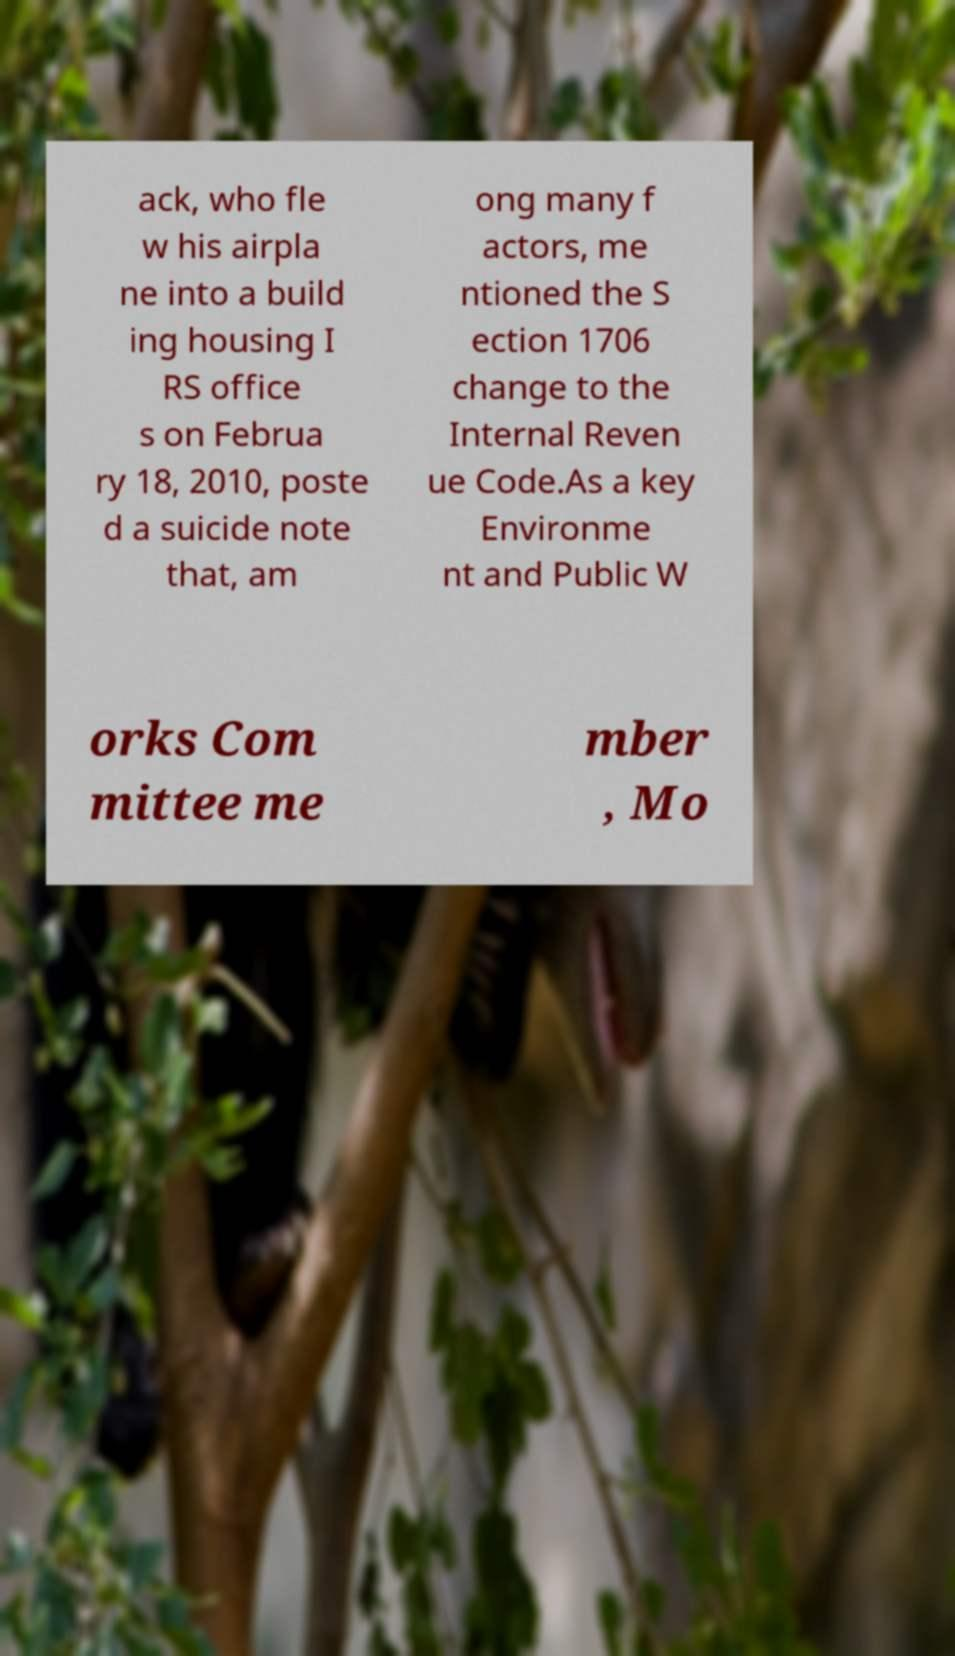Can you accurately transcribe the text from the provided image for me? ack, who fle w his airpla ne into a build ing housing I RS office s on Februa ry 18, 2010, poste d a suicide note that, am ong many f actors, me ntioned the S ection 1706 change to the Internal Reven ue Code.As a key Environme nt and Public W orks Com mittee me mber , Mo 